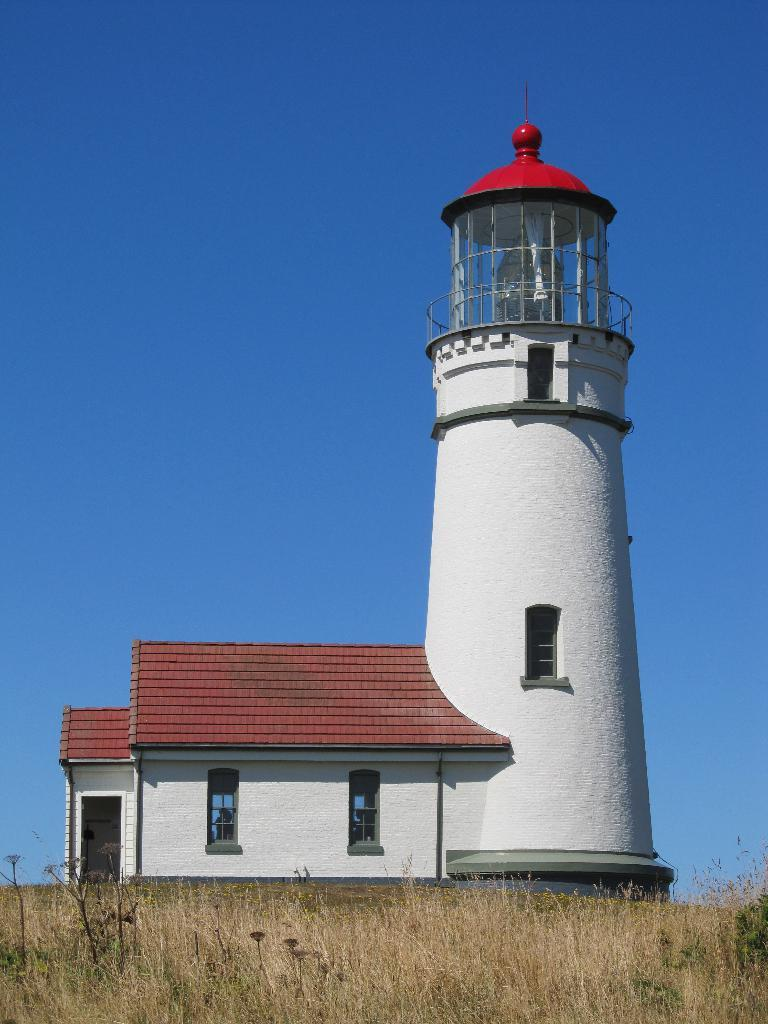What is the main structure in the center of the image? There is a lighthouse in the center of the image. What type of vegetation covers the ground in the image? The ground in the image is covered with grass. What is visible at the top of the image? The sky is visible at the top of the image. How many minutes does it take for the fog to clear in the image? There is no mention of fog in the image, so it is not possible to determine how long it would take for the fog to clear. 